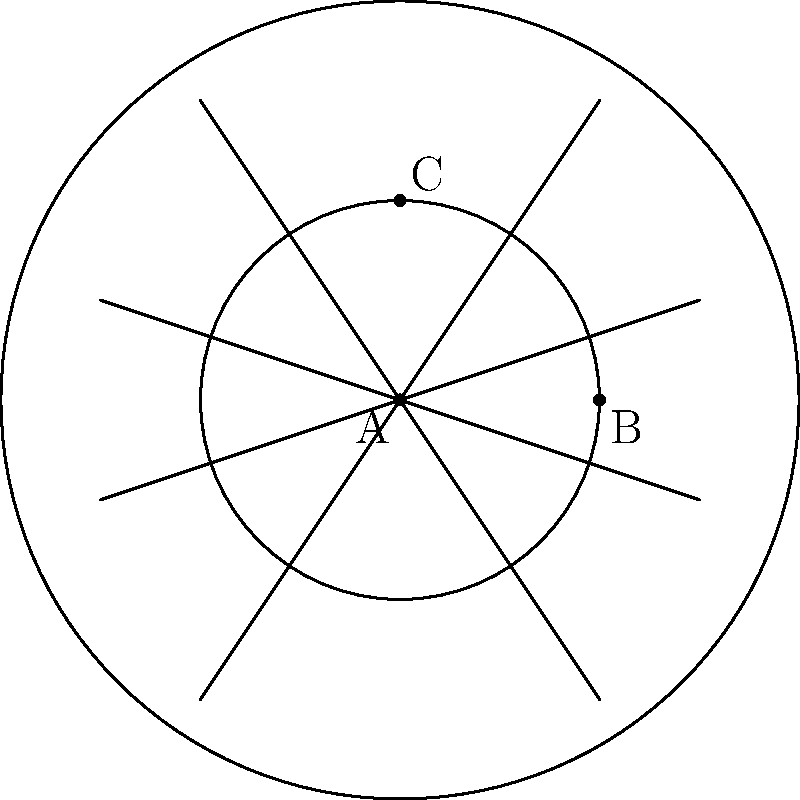In the topological representation of a dreamcatcher design shown above, what is the genus of the surface formed by the string pattern within the outer circle, excluding the inner circle? To determine the genus of the surface formed by the string pattern, we need to follow these steps:

1. Identify the number of regions created by the string pattern:
   The string pattern divides the area between the outer and inner circles into several regions.

2. Count the number of edges (E):
   Each string segment between intersections is an edge.

3. Count the number of vertices (V):
   Vertices are formed where strings intersect, including points on the circles.

4. Count the number of faces (F):
   Faces are the distinct regions created by the string pattern, including the inner circle.

5. Apply Euler's formula for planar graphs: $V - E + F = 2$

6. Calculate the genus (g) using the formula: $g = 1 - \frac{1}{2}(V - E + F)$

In this dreamcatcher design:
- Edges (E): 16 (counting string segments between intersections)
- Vertices (V): 9 (counting intersection points, including those on circles)
- Faces (F): 9 (counting regions created by strings, including the inner circle)

Applying Euler's formula:
$9 - 16 + 9 = 2$

Now, calculate the genus:
$g = 1 - \frac{1}{2}(9 - 16 + 9) = 1 - \frac{1}{2}(2) = 1 - 1 = 0$

Therefore, the genus of the surface formed by the string pattern is 0, which topologically equivalent to a sphere with holes (the inner circle and outer boundary).
Answer: 0 